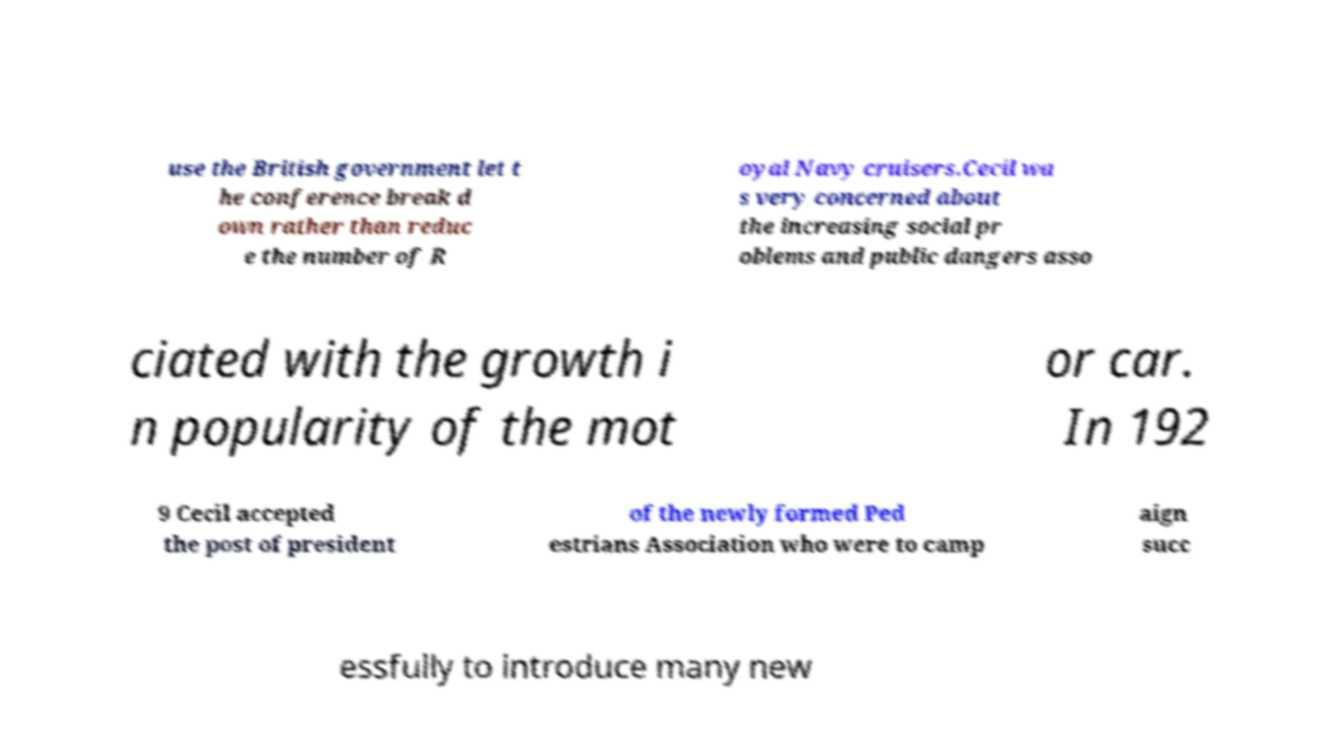Please identify and transcribe the text found in this image. use the British government let t he conference break d own rather than reduc e the number of R oyal Navy cruisers.Cecil wa s very concerned about the increasing social pr oblems and public dangers asso ciated with the growth i n popularity of the mot or car. In 192 9 Cecil accepted the post of president of the newly formed Ped estrians Association who were to camp aign succ essfully to introduce many new 